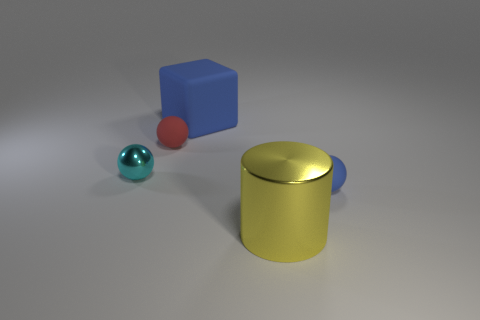Could you imagine what sort of environment these objects might belong to? Certainly. Given their simple geometric shapes and the clean, unadorned surfaces, these objects might belong in an educational setting like a classroom, where they could be used for instructional purposes, perhaps to teach geometry or spatial concepts. Alternatively, they could be part of a minimalist art installation or a designer's modeling software for creating 3D scenes. 